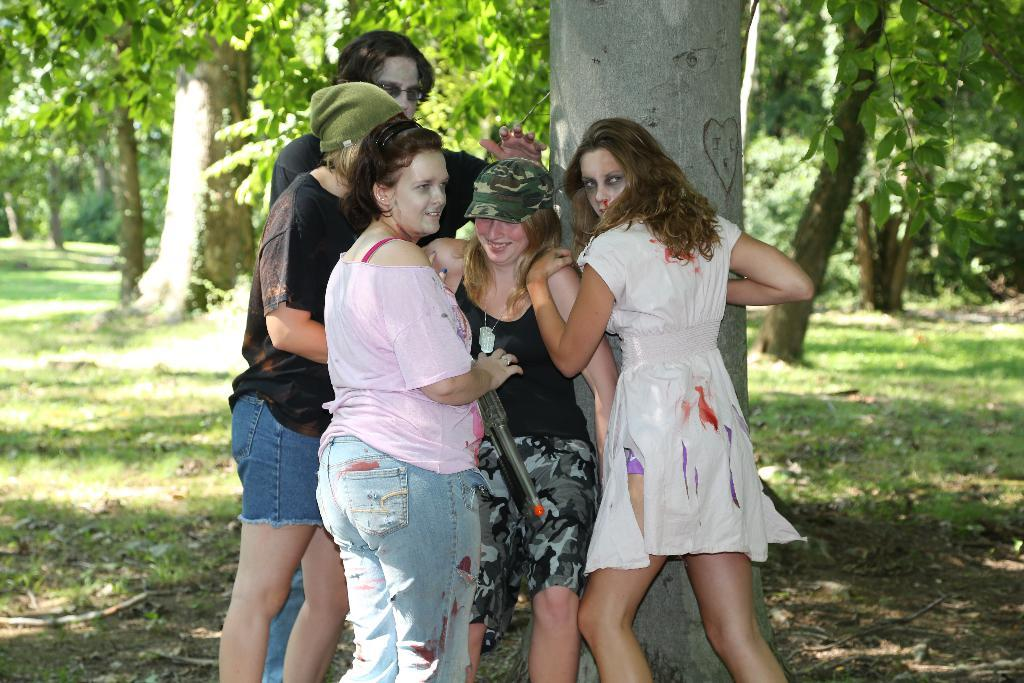Who is the main subject in the image? There is a woman in the image. What is the woman's relationship with the other people in the image? The woman is surrounded by a group of people. What type of natural environment is visible in the background of the image? There are trees visible in the background of the image. What type of surface is the woman standing on? There is grass on the surface in the image. What mathematical operation is the woman performing in the image? There is no indication in the image that the woman is performing any mathematical operation. 